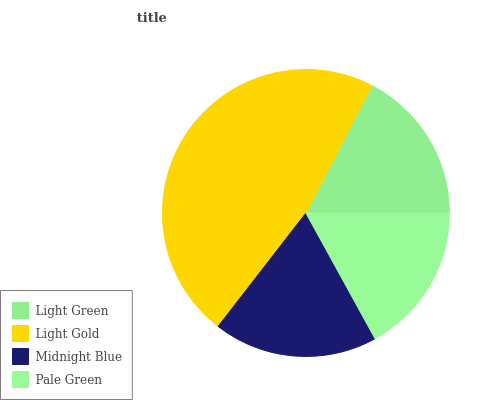Is Pale Green the minimum?
Answer yes or no. Yes. Is Light Gold the maximum?
Answer yes or no. Yes. Is Midnight Blue the minimum?
Answer yes or no. No. Is Midnight Blue the maximum?
Answer yes or no. No. Is Light Gold greater than Midnight Blue?
Answer yes or no. Yes. Is Midnight Blue less than Light Gold?
Answer yes or no. Yes. Is Midnight Blue greater than Light Gold?
Answer yes or no. No. Is Light Gold less than Midnight Blue?
Answer yes or no. No. Is Midnight Blue the high median?
Answer yes or no. Yes. Is Light Green the low median?
Answer yes or no. Yes. Is Light Green the high median?
Answer yes or no. No. Is Light Gold the low median?
Answer yes or no. No. 